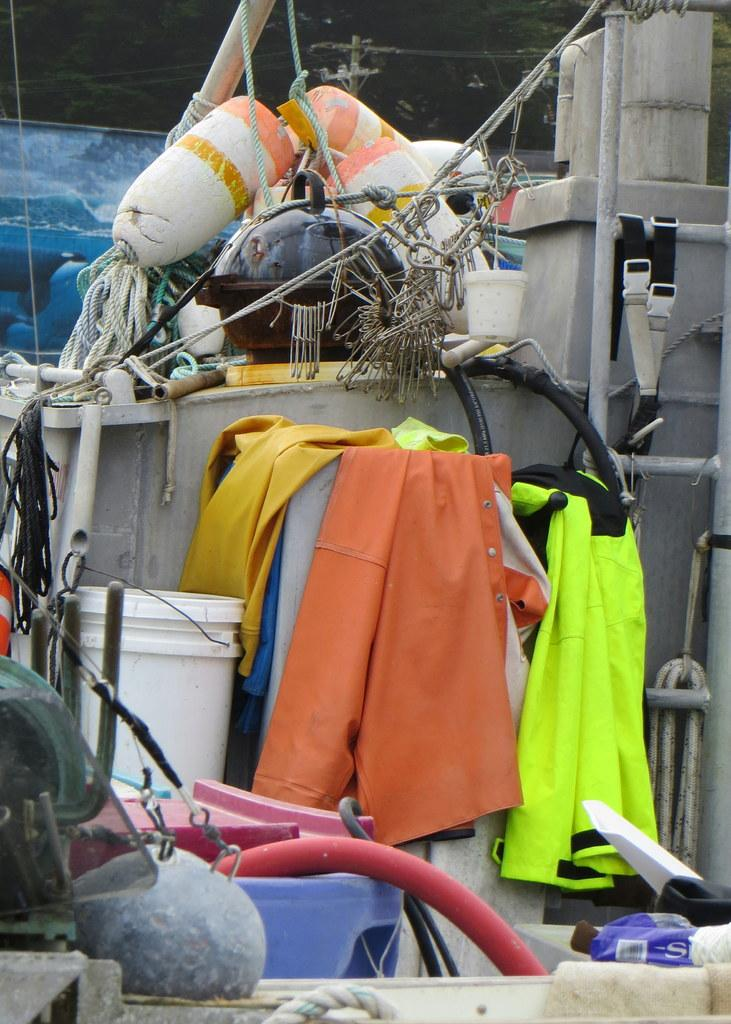What type of items can be seen in the image? There are clothes, a bucket, a pipe, ropes, a lid, a ladder, and other unspecified objects in the image. Can you describe the location of the current pole in the image? The current pole is at the top of the image. What might be used for carrying or holding items in the image? The bucket, ropes, and lid could be used for carrying or holding items. What is the purpose of the ladder in the image? The ladder might be used for reaching higher areas or climbing up. What type of sweater is being worn by the air in the image? There is no air or sweater present in the image. How does the breath of the person in the image affect the clothes? There is no person or breath visible in the image, so it is not possible to determine any effect on the clothes. 